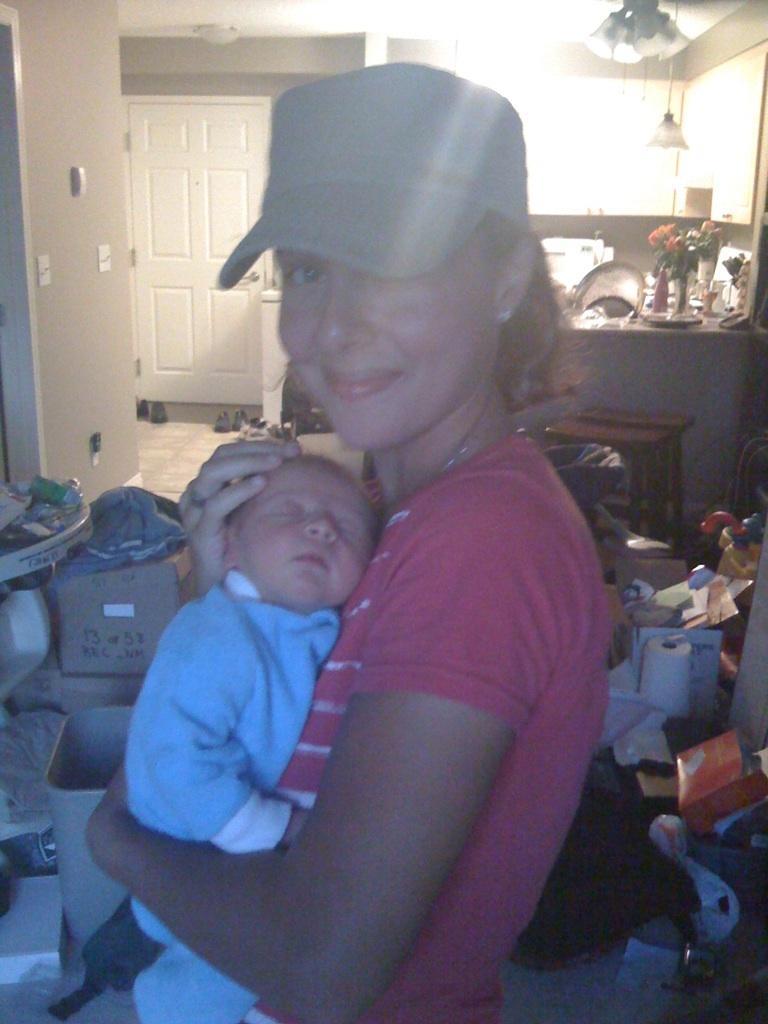How would you summarize this image in a sentence or two? In this picture there is a woman who is holding a baby. She is smiling. In the back I can see the door and table. On the table I can see the plates, box and other objects. On the floor I can see the cotton boxes, tissue papers, clothes, plastic covers, bags, papers, pads and other objects. In the top right corner I can see the lights. 